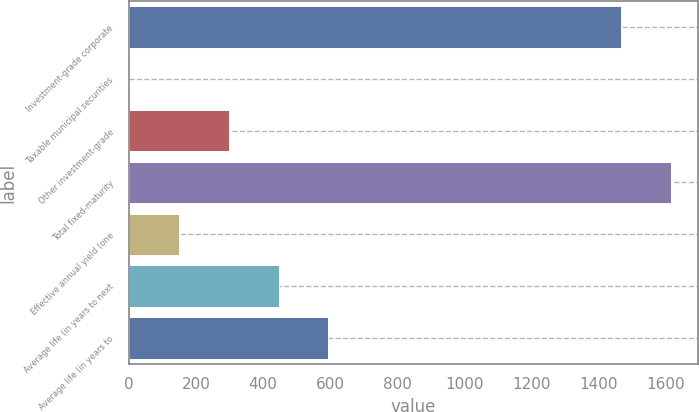Convert chart to OTSL. <chart><loc_0><loc_0><loc_500><loc_500><bar_chart><fcel>Investment-grade corporate<fcel>Taxable municipal securities<fcel>Other investment-grade<fcel>Total fixed-maturity<fcel>Effective annual yield (one<fcel>Average life (in years to next<fcel>Average life (in years to<nl><fcel>1465.9<fcel>1.5<fcel>298.06<fcel>1614.18<fcel>149.78<fcel>446.34<fcel>594.62<nl></chart> 